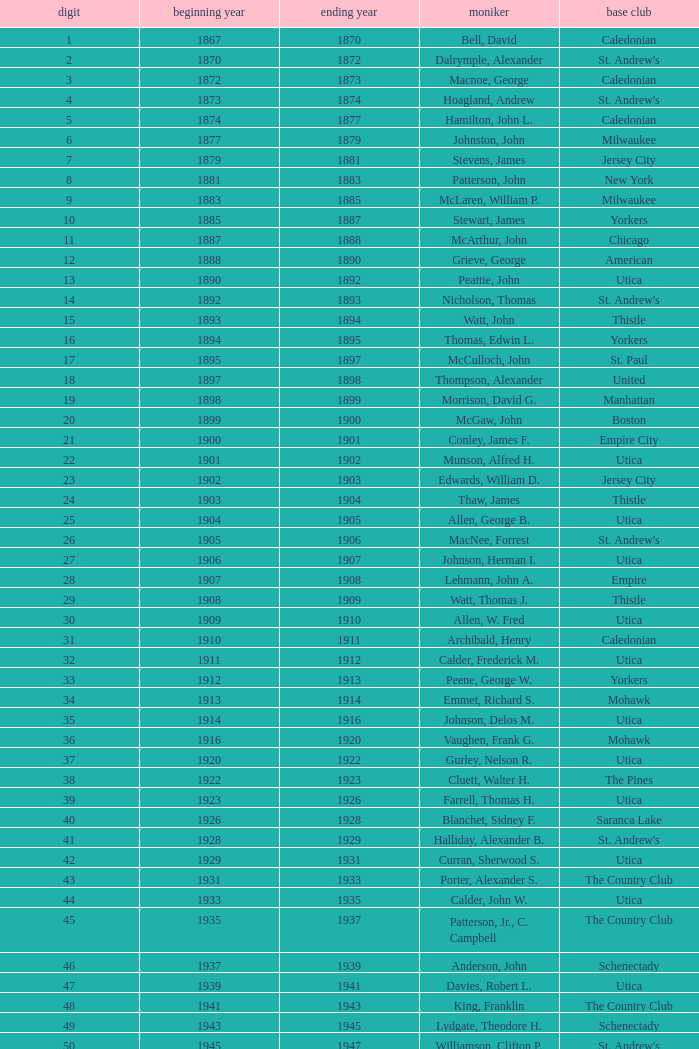Which Number has a Home Club of broomstones, and a Year End smaller than 1999? None. 